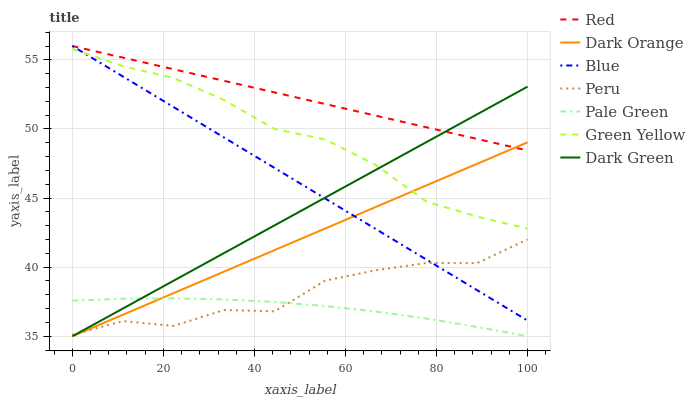Does Pale Green have the minimum area under the curve?
Answer yes or no. Yes. Does Red have the maximum area under the curve?
Answer yes or no. Yes. Does Dark Orange have the minimum area under the curve?
Answer yes or no. No. Does Dark Orange have the maximum area under the curve?
Answer yes or no. No. Is Dark Orange the smoothest?
Answer yes or no. Yes. Is Peru the roughest?
Answer yes or no. Yes. Is Pale Green the smoothest?
Answer yes or no. No. Is Pale Green the roughest?
Answer yes or no. No. Does Dark Orange have the lowest value?
Answer yes or no. Yes. Does Peru have the lowest value?
Answer yes or no. No. Does Red have the highest value?
Answer yes or no. Yes. Does Dark Orange have the highest value?
Answer yes or no. No. Is Peru less than Red?
Answer yes or no. Yes. Is Red greater than Peru?
Answer yes or no. Yes. Does Dark Orange intersect Pale Green?
Answer yes or no. Yes. Is Dark Orange less than Pale Green?
Answer yes or no. No. Is Dark Orange greater than Pale Green?
Answer yes or no. No. Does Peru intersect Red?
Answer yes or no. No. 